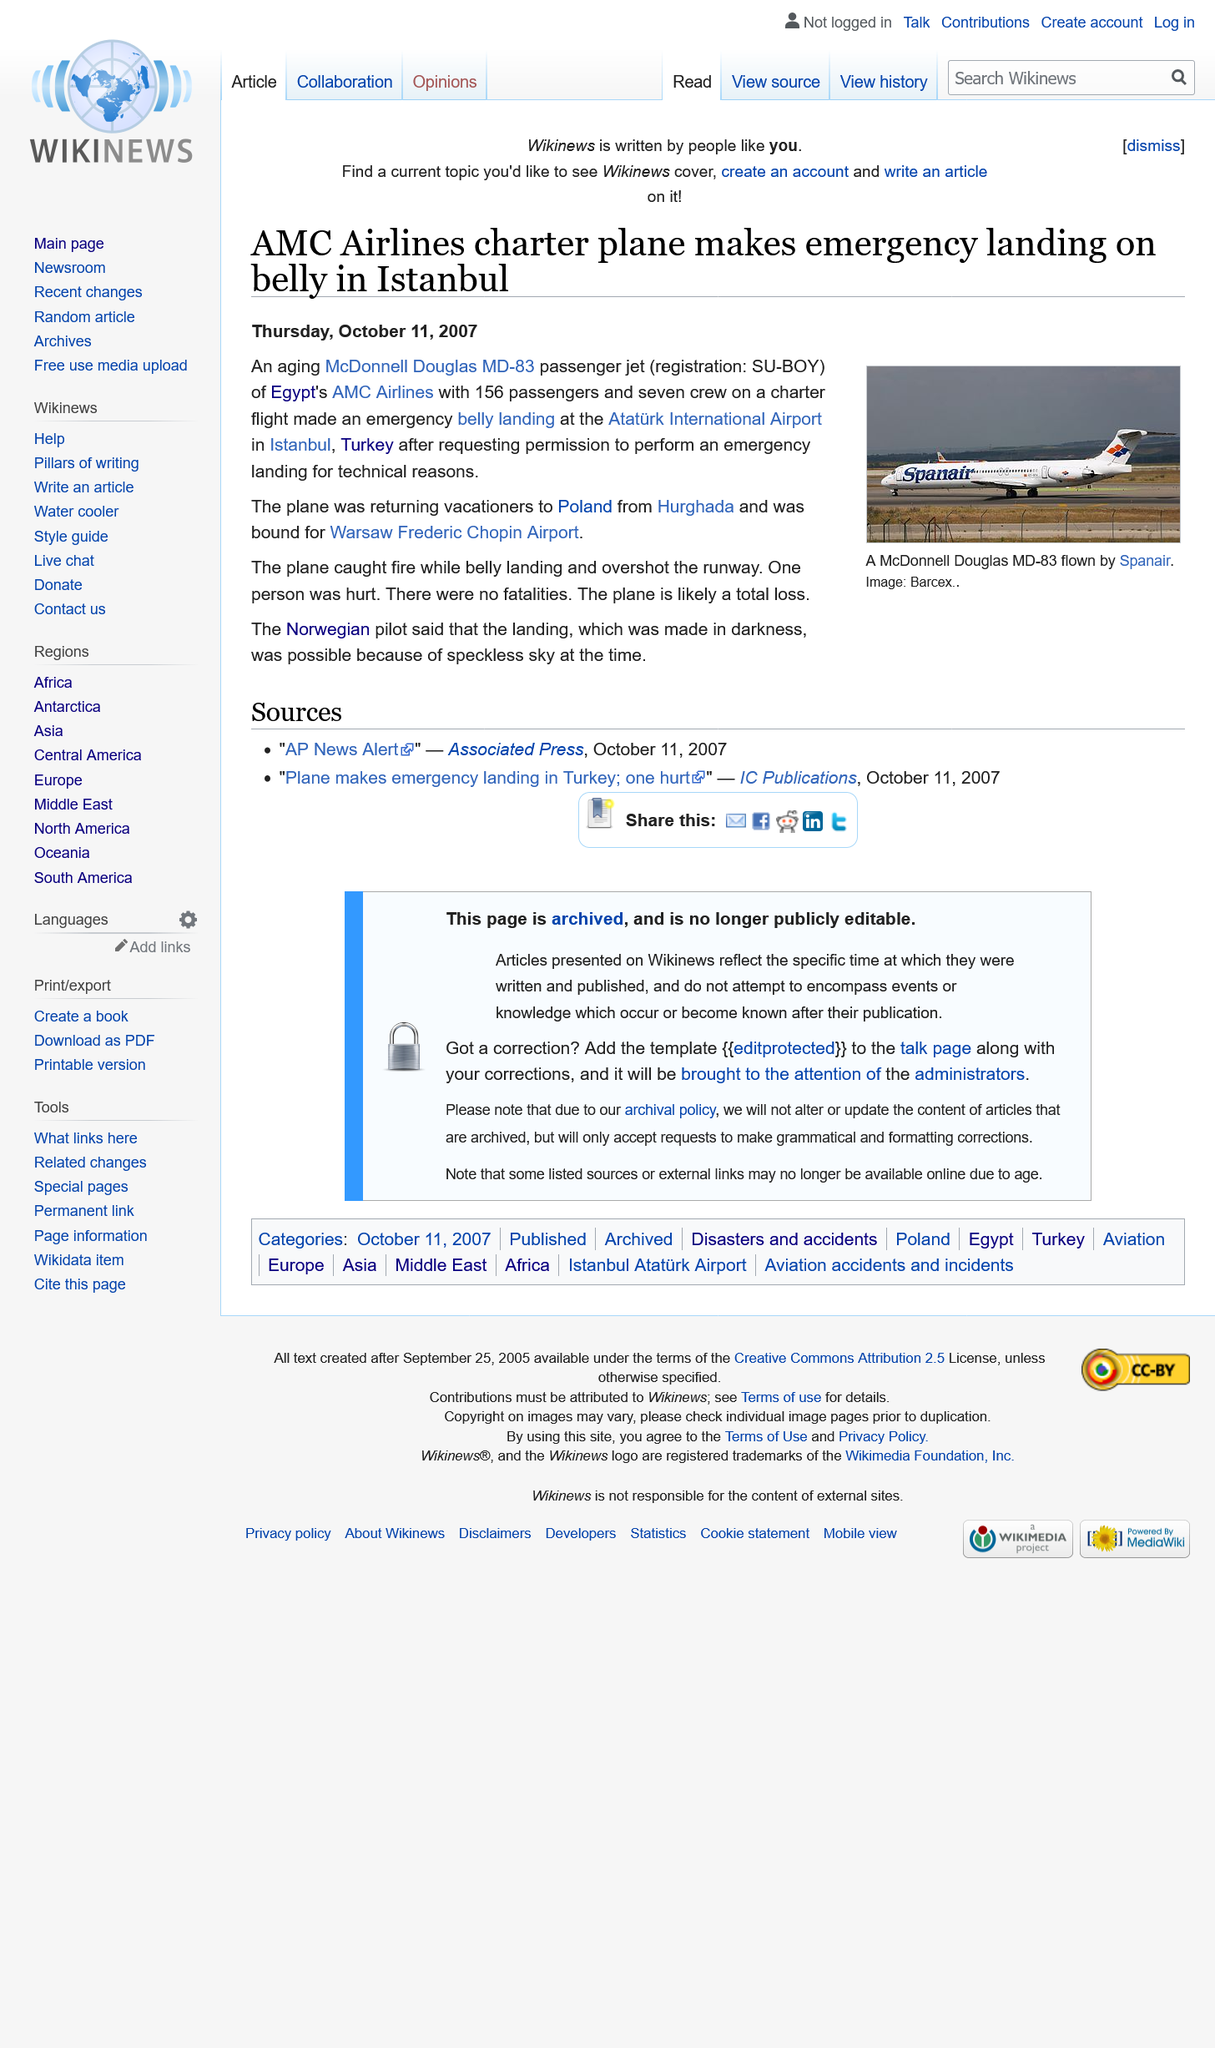Point out several critical features in this image. The image depicts a McDonnell Douglas MS-83 aircraft, operated by Spanair, in flight. The article was published on Thursday, October 11th, 2007. The number of people aboard the plane was 156 passengers and 7 crew members. 